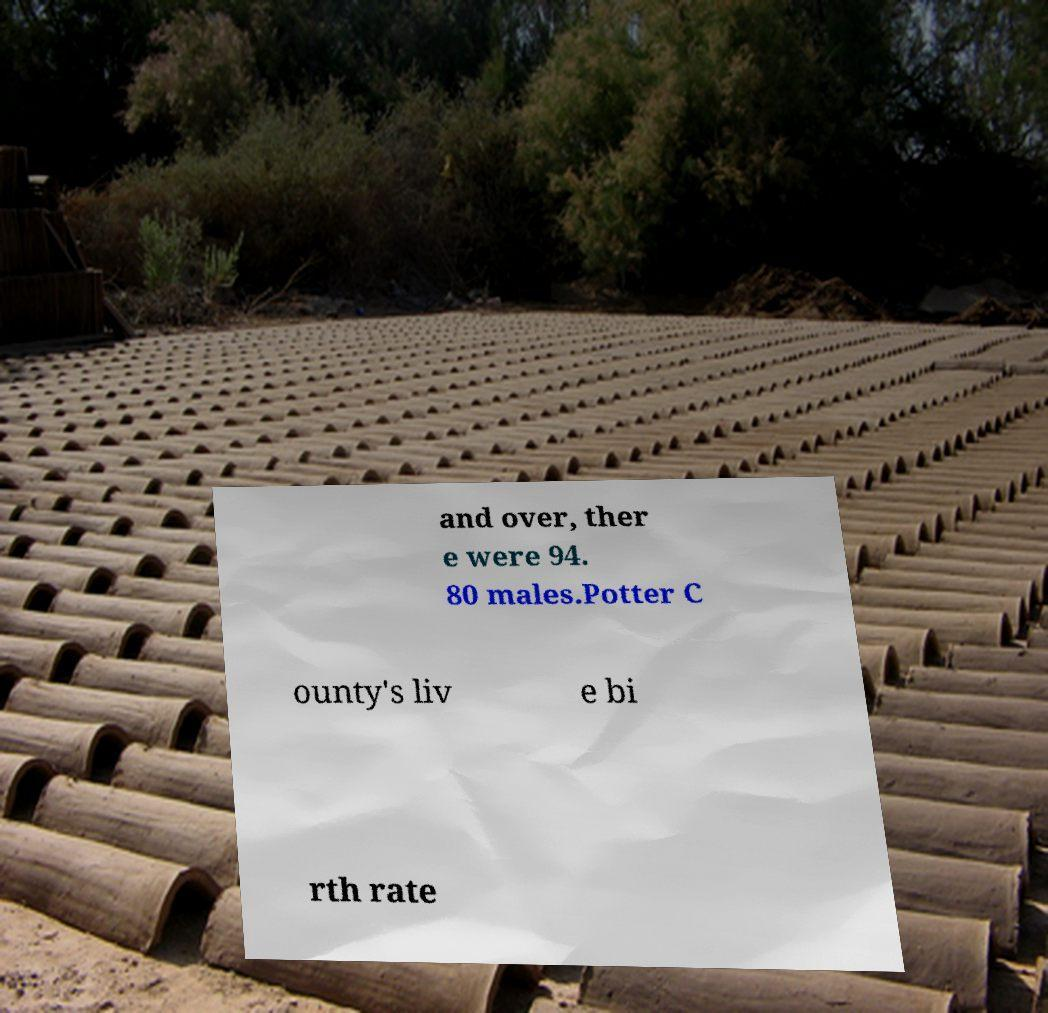Could you extract and type out the text from this image? and over, ther e were 94. 80 males.Potter C ounty's liv e bi rth rate 